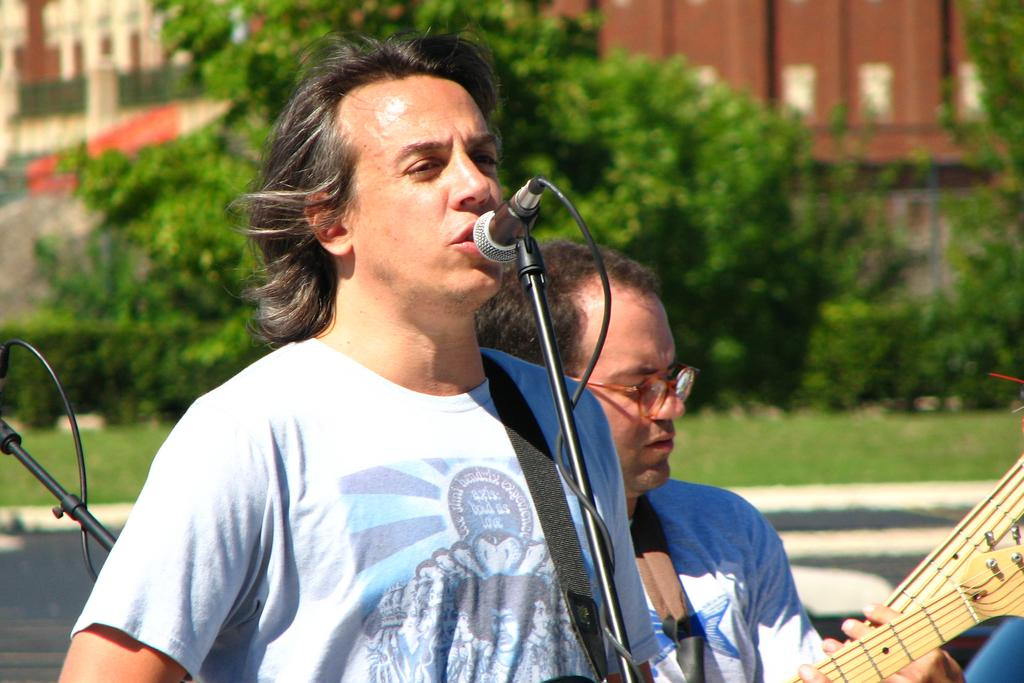What is the man in the image doing? The man is standing and singing a song. What is the man holding while singing? There is a microphone with a microphone stand in the image. Is there another person in the image? Yes, there is another man standing and playing a guitar. What can be seen in the background of the image? There are trees and bushes in the background of the image. What type of bomb is being diffused in the image? There is no bomb present in the image; it features a man singing with a microphone and another man playing a guitar. How many rings can be seen on the fingers of the guitar player? There is no mention of rings in the image, as it focuses on the musical performance and the surrounding environment. 